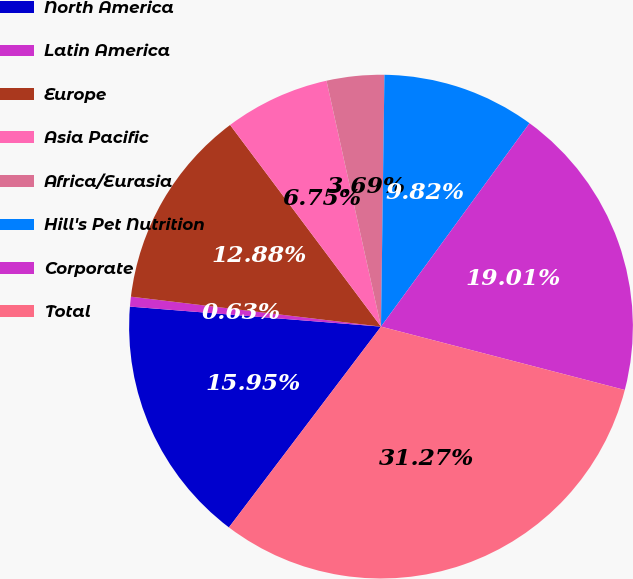Convert chart to OTSL. <chart><loc_0><loc_0><loc_500><loc_500><pie_chart><fcel>North America<fcel>Latin America<fcel>Europe<fcel>Asia Pacific<fcel>Africa/Eurasia<fcel>Hill's Pet Nutrition<fcel>Corporate<fcel>Total<nl><fcel>15.95%<fcel>0.63%<fcel>12.88%<fcel>6.75%<fcel>3.69%<fcel>9.82%<fcel>19.01%<fcel>31.27%<nl></chart> 